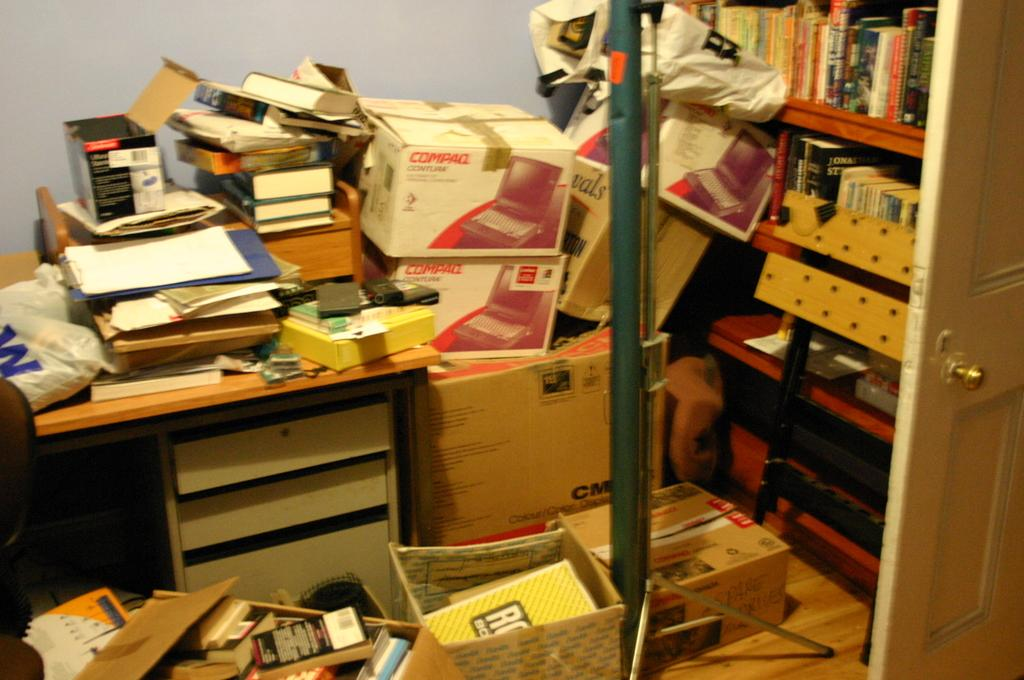What is on the bookshelf in the image? There are books on a bookshelf in the image. What is on the table in the image? There are boxes on a table in the image. How many trees are visible in the image? There are no trees visible in the image; it only shows books on a bookshelf and boxes on a table. What type of feather can be seen in the image? There is no feather present in the image. 